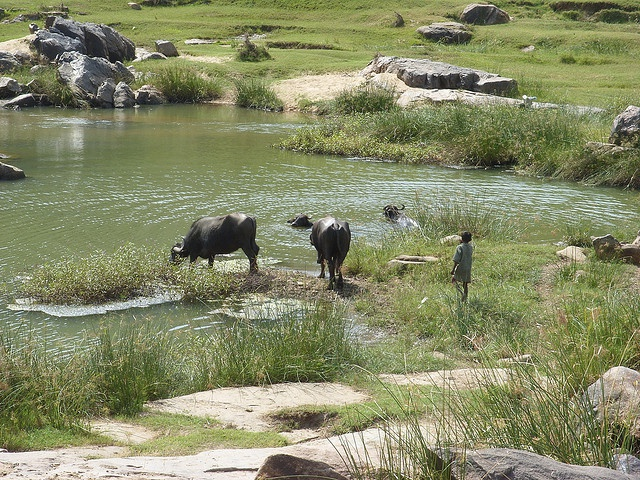Describe the objects in this image and their specific colors. I can see cow in olive, black, gray, and darkgray tones, cow in olive, black, gray, darkgray, and lightgray tones, people in olive, black, gray, and darkgreen tones, cow in olive, darkgray, gray, black, and lightgray tones, and cow in olive, black, darkgray, and gray tones in this image. 